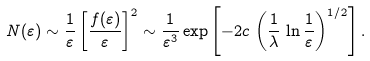<formula> <loc_0><loc_0><loc_500><loc_500>N ( \varepsilon ) \sim \frac { 1 } { \varepsilon } \left [ \frac { f ( \varepsilon ) } { \varepsilon } \right ] ^ { 2 } \sim \frac { 1 } { \varepsilon ^ { 3 } } \exp \left [ - 2 c \, \left ( \frac { 1 } { \lambda } \, \ln \frac { 1 } { \varepsilon } \right ) ^ { 1 / 2 } \right ] .</formula> 